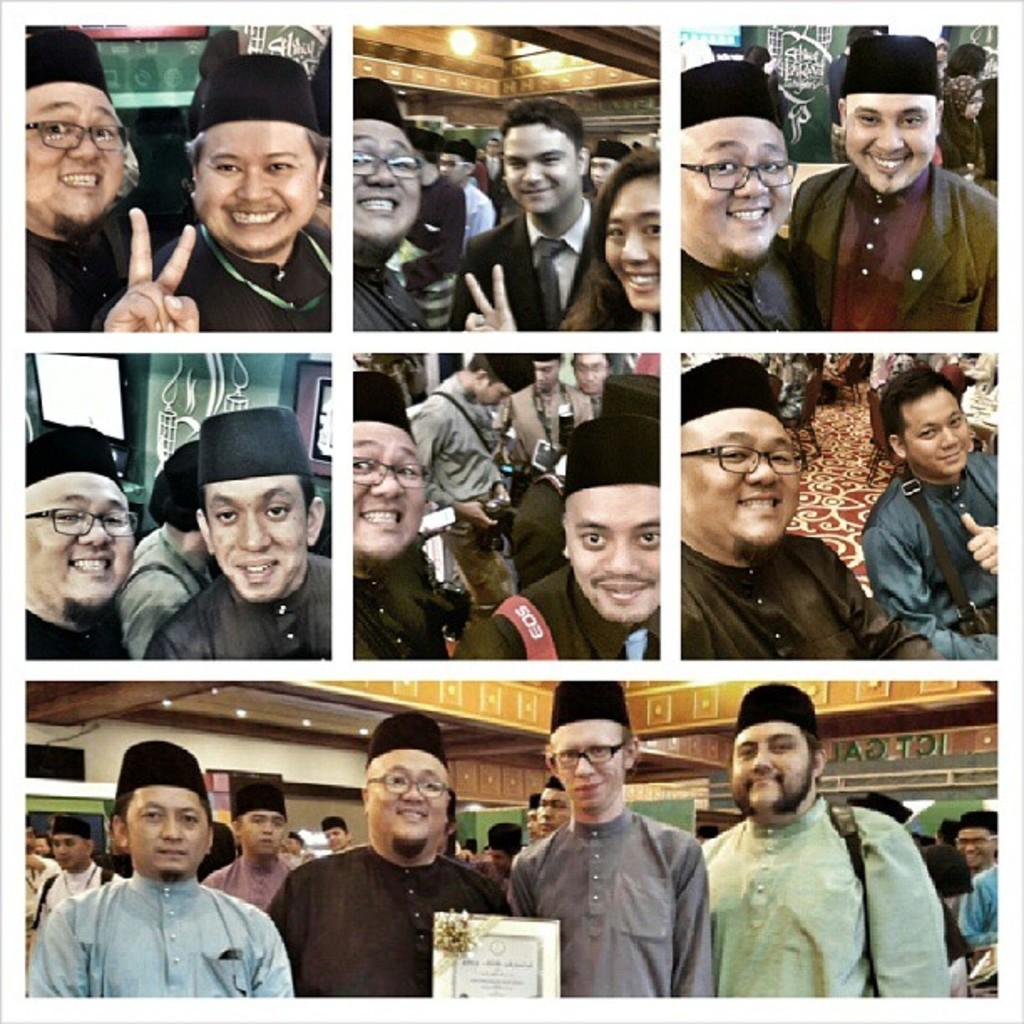What is the main subject of the image? The main subject of the image is a collage of photos. Can you describe the people at the bottom of the image? There are persons wearing caps at the bottom of the image. What else is present in the image besides the collage of photos? There is a frame with text in the image. How many yaks can be seen in the image? There are no yaks present in the image. What type of pin is holding the frame in place? There is no pin visible in the image, and the frame's position is not mentioned in the provided facts. 